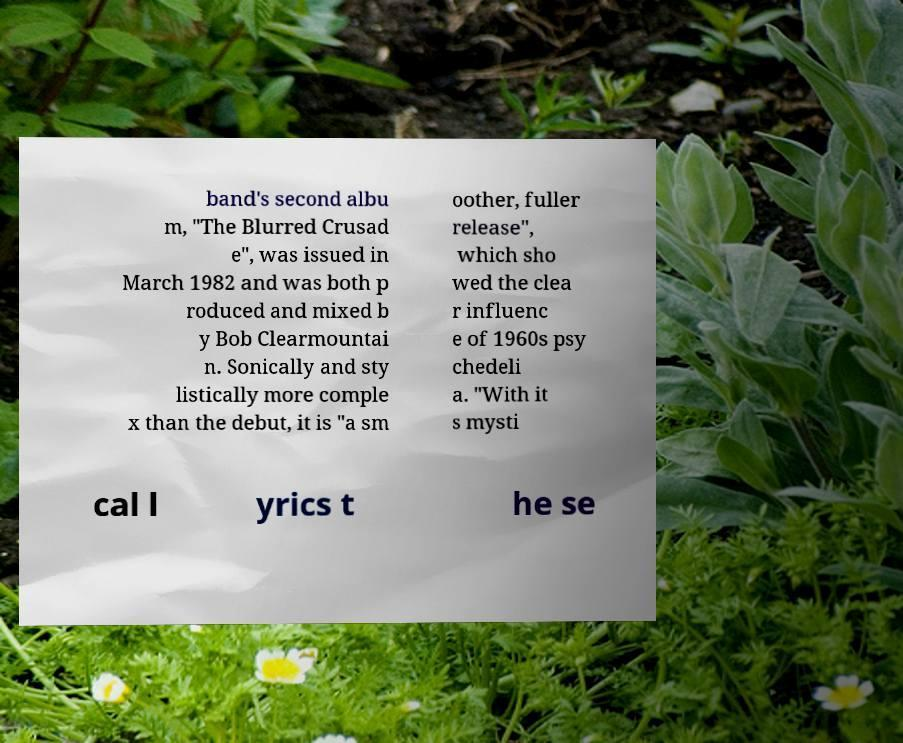Please identify and transcribe the text found in this image. band's second albu m, "The Blurred Crusad e", was issued in March 1982 and was both p roduced and mixed b y Bob Clearmountai n. Sonically and sty listically more comple x than the debut, it is "a sm oother, fuller release", which sho wed the clea r influenc e of 1960s psy chedeli a. "With it s mysti cal l yrics t he se 